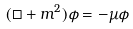<formula> <loc_0><loc_0><loc_500><loc_500>( \Box + m ^ { 2 } ) \phi = - \mu \phi</formula> 